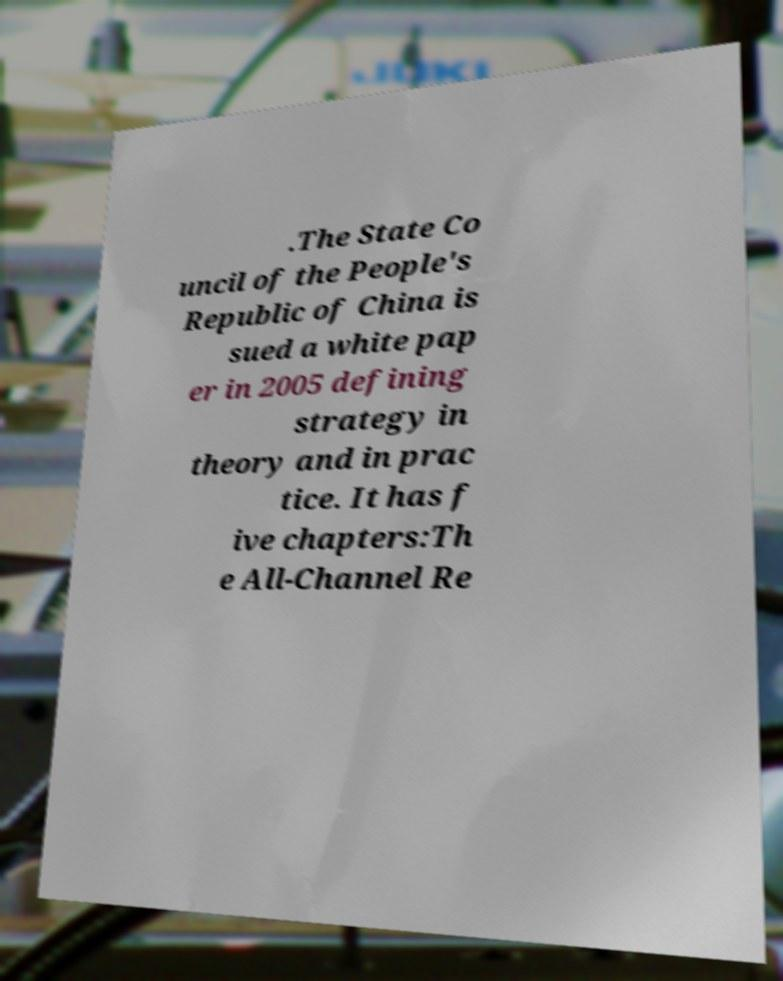Please read and relay the text visible in this image. What does it say? .The State Co uncil of the People's Republic of China is sued a white pap er in 2005 defining strategy in theory and in prac tice. It has f ive chapters:Th e All-Channel Re 